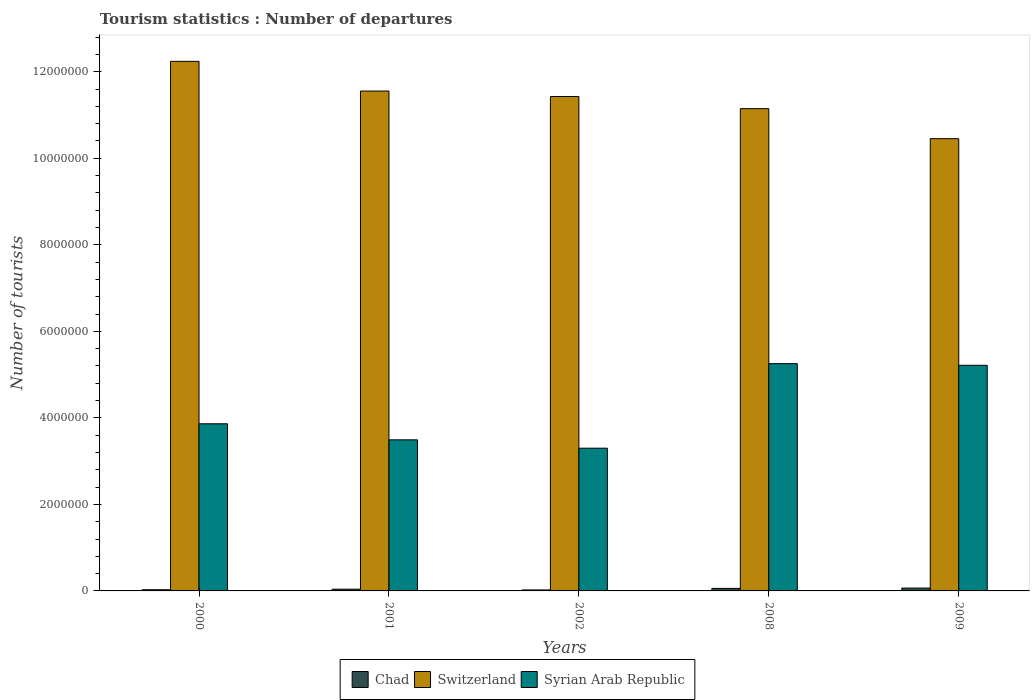How many different coloured bars are there?
Offer a very short reply. 3. What is the label of the 4th group of bars from the left?
Give a very brief answer. 2008. What is the number of tourist departures in Syrian Arab Republic in 2008?
Provide a succinct answer. 5.25e+06. Across all years, what is the maximum number of tourist departures in Chad?
Keep it short and to the point. 6.60e+04. Across all years, what is the minimum number of tourist departures in Syrian Arab Republic?
Your answer should be compact. 3.30e+06. In which year was the number of tourist departures in Syrian Arab Republic minimum?
Ensure brevity in your answer.  2002. What is the total number of tourist departures in Chad in the graph?
Offer a very short reply. 2.14e+05. What is the difference between the number of tourist departures in Switzerland in 2000 and that in 2001?
Give a very brief answer. 6.86e+05. What is the difference between the number of tourist departures in Chad in 2009 and the number of tourist departures in Syrian Arab Republic in 2001?
Your answer should be very brief. -3.43e+06. What is the average number of tourist departures in Switzerland per year?
Provide a short and direct response. 1.14e+07. In the year 2002, what is the difference between the number of tourist departures in Syrian Arab Republic and number of tourist departures in Chad?
Keep it short and to the point. 3.28e+06. In how many years, is the number of tourist departures in Switzerland greater than 8800000?
Provide a short and direct response. 5. What is the ratio of the number of tourist departures in Switzerland in 2001 to that in 2008?
Provide a succinct answer. 1.04. What is the difference between the highest and the second highest number of tourist departures in Chad?
Your answer should be very brief. 8000. What is the difference between the highest and the lowest number of tourist departures in Switzerland?
Your answer should be very brief. 1.79e+06. Is the sum of the number of tourist departures in Switzerland in 2000 and 2001 greater than the maximum number of tourist departures in Chad across all years?
Ensure brevity in your answer.  Yes. What does the 1st bar from the left in 2009 represents?
Provide a short and direct response. Chad. What does the 3rd bar from the right in 2002 represents?
Give a very brief answer. Chad. Is it the case that in every year, the sum of the number of tourist departures in Switzerland and number of tourist departures in Syrian Arab Republic is greater than the number of tourist departures in Chad?
Your response must be concise. Yes. How many bars are there?
Offer a terse response. 15. Are all the bars in the graph horizontal?
Make the answer very short. No. How many years are there in the graph?
Offer a very short reply. 5. What is the difference between two consecutive major ticks on the Y-axis?
Provide a succinct answer. 2.00e+06. Are the values on the major ticks of Y-axis written in scientific E-notation?
Offer a very short reply. No. Does the graph contain any zero values?
Provide a succinct answer. No. Does the graph contain grids?
Your answer should be compact. No. Where does the legend appear in the graph?
Make the answer very short. Bottom center. How are the legend labels stacked?
Keep it short and to the point. Horizontal. What is the title of the graph?
Offer a very short reply. Tourism statistics : Number of departures. What is the label or title of the X-axis?
Make the answer very short. Years. What is the label or title of the Y-axis?
Provide a short and direct response. Number of tourists. What is the Number of tourists in Chad in 2000?
Ensure brevity in your answer.  2.70e+04. What is the Number of tourists in Switzerland in 2000?
Offer a terse response. 1.22e+07. What is the Number of tourists of Syrian Arab Republic in 2000?
Ensure brevity in your answer.  3.86e+06. What is the Number of tourists in Chad in 2001?
Offer a terse response. 4.00e+04. What is the Number of tourists in Switzerland in 2001?
Make the answer very short. 1.16e+07. What is the Number of tourists in Syrian Arab Republic in 2001?
Your answer should be compact. 3.49e+06. What is the Number of tourists in Chad in 2002?
Provide a short and direct response. 2.30e+04. What is the Number of tourists in Switzerland in 2002?
Offer a very short reply. 1.14e+07. What is the Number of tourists in Syrian Arab Republic in 2002?
Provide a succinct answer. 3.30e+06. What is the Number of tourists of Chad in 2008?
Keep it short and to the point. 5.80e+04. What is the Number of tourists in Switzerland in 2008?
Give a very brief answer. 1.11e+07. What is the Number of tourists of Syrian Arab Republic in 2008?
Your answer should be very brief. 5.25e+06. What is the Number of tourists in Chad in 2009?
Your answer should be very brief. 6.60e+04. What is the Number of tourists of Switzerland in 2009?
Keep it short and to the point. 1.05e+07. What is the Number of tourists in Syrian Arab Republic in 2009?
Offer a very short reply. 5.22e+06. Across all years, what is the maximum Number of tourists in Chad?
Your answer should be very brief. 6.60e+04. Across all years, what is the maximum Number of tourists in Switzerland?
Offer a very short reply. 1.22e+07. Across all years, what is the maximum Number of tourists of Syrian Arab Republic?
Provide a short and direct response. 5.25e+06. Across all years, what is the minimum Number of tourists of Chad?
Keep it short and to the point. 2.30e+04. Across all years, what is the minimum Number of tourists of Switzerland?
Ensure brevity in your answer.  1.05e+07. Across all years, what is the minimum Number of tourists in Syrian Arab Republic?
Make the answer very short. 3.30e+06. What is the total Number of tourists in Chad in the graph?
Provide a succinct answer. 2.14e+05. What is the total Number of tourists of Switzerland in the graph?
Keep it short and to the point. 5.68e+07. What is the total Number of tourists of Syrian Arab Republic in the graph?
Give a very brief answer. 2.11e+07. What is the difference between the Number of tourists in Chad in 2000 and that in 2001?
Keep it short and to the point. -1.30e+04. What is the difference between the Number of tourists in Switzerland in 2000 and that in 2001?
Provide a succinct answer. 6.86e+05. What is the difference between the Number of tourists in Syrian Arab Republic in 2000 and that in 2001?
Keep it short and to the point. 3.71e+05. What is the difference between the Number of tourists of Chad in 2000 and that in 2002?
Your answer should be compact. 4000. What is the difference between the Number of tourists of Switzerland in 2000 and that in 2002?
Give a very brief answer. 8.13e+05. What is the difference between the Number of tourists of Syrian Arab Republic in 2000 and that in 2002?
Ensure brevity in your answer.  5.64e+05. What is the difference between the Number of tourists in Chad in 2000 and that in 2008?
Keep it short and to the point. -3.10e+04. What is the difference between the Number of tourists of Switzerland in 2000 and that in 2008?
Your response must be concise. 1.09e+06. What is the difference between the Number of tourists in Syrian Arab Republic in 2000 and that in 2008?
Offer a terse response. -1.39e+06. What is the difference between the Number of tourists in Chad in 2000 and that in 2009?
Provide a succinct answer. -3.90e+04. What is the difference between the Number of tourists in Switzerland in 2000 and that in 2009?
Offer a terse response. 1.79e+06. What is the difference between the Number of tourists in Syrian Arab Republic in 2000 and that in 2009?
Your response must be concise. -1.35e+06. What is the difference between the Number of tourists in Chad in 2001 and that in 2002?
Your answer should be very brief. 1.70e+04. What is the difference between the Number of tourists in Switzerland in 2001 and that in 2002?
Your response must be concise. 1.27e+05. What is the difference between the Number of tourists of Syrian Arab Republic in 2001 and that in 2002?
Your answer should be very brief. 1.93e+05. What is the difference between the Number of tourists of Chad in 2001 and that in 2008?
Offer a terse response. -1.80e+04. What is the difference between the Number of tourists in Switzerland in 2001 and that in 2008?
Ensure brevity in your answer.  4.07e+05. What is the difference between the Number of tourists in Syrian Arab Republic in 2001 and that in 2008?
Provide a short and direct response. -1.76e+06. What is the difference between the Number of tourists in Chad in 2001 and that in 2009?
Offer a very short reply. -2.60e+04. What is the difference between the Number of tourists in Switzerland in 2001 and that in 2009?
Your answer should be very brief. 1.10e+06. What is the difference between the Number of tourists in Syrian Arab Republic in 2001 and that in 2009?
Your response must be concise. -1.72e+06. What is the difference between the Number of tourists of Chad in 2002 and that in 2008?
Offer a terse response. -3.50e+04. What is the difference between the Number of tourists in Switzerland in 2002 and that in 2008?
Keep it short and to the point. 2.80e+05. What is the difference between the Number of tourists in Syrian Arab Republic in 2002 and that in 2008?
Provide a short and direct response. -1.95e+06. What is the difference between the Number of tourists in Chad in 2002 and that in 2009?
Your answer should be compact. -4.30e+04. What is the difference between the Number of tourists of Switzerland in 2002 and that in 2009?
Your answer should be very brief. 9.74e+05. What is the difference between the Number of tourists in Syrian Arab Republic in 2002 and that in 2009?
Keep it short and to the point. -1.92e+06. What is the difference between the Number of tourists of Chad in 2008 and that in 2009?
Your answer should be compact. -8000. What is the difference between the Number of tourists in Switzerland in 2008 and that in 2009?
Keep it short and to the point. 6.94e+05. What is the difference between the Number of tourists of Syrian Arab Republic in 2008 and that in 2009?
Your response must be concise. 3.80e+04. What is the difference between the Number of tourists of Chad in 2000 and the Number of tourists of Switzerland in 2001?
Keep it short and to the point. -1.15e+07. What is the difference between the Number of tourists in Chad in 2000 and the Number of tourists in Syrian Arab Republic in 2001?
Your response must be concise. -3.46e+06. What is the difference between the Number of tourists in Switzerland in 2000 and the Number of tourists in Syrian Arab Republic in 2001?
Offer a very short reply. 8.75e+06. What is the difference between the Number of tourists of Chad in 2000 and the Number of tourists of Switzerland in 2002?
Your answer should be very brief. -1.14e+07. What is the difference between the Number of tourists in Chad in 2000 and the Number of tourists in Syrian Arab Republic in 2002?
Your response must be concise. -3.27e+06. What is the difference between the Number of tourists in Switzerland in 2000 and the Number of tourists in Syrian Arab Republic in 2002?
Offer a very short reply. 8.94e+06. What is the difference between the Number of tourists of Chad in 2000 and the Number of tourists of Switzerland in 2008?
Provide a succinct answer. -1.11e+07. What is the difference between the Number of tourists in Chad in 2000 and the Number of tourists in Syrian Arab Republic in 2008?
Your response must be concise. -5.23e+06. What is the difference between the Number of tourists in Switzerland in 2000 and the Number of tourists in Syrian Arab Republic in 2008?
Provide a short and direct response. 6.99e+06. What is the difference between the Number of tourists of Chad in 2000 and the Number of tourists of Switzerland in 2009?
Ensure brevity in your answer.  -1.04e+07. What is the difference between the Number of tourists in Chad in 2000 and the Number of tourists in Syrian Arab Republic in 2009?
Offer a very short reply. -5.19e+06. What is the difference between the Number of tourists of Switzerland in 2000 and the Number of tourists of Syrian Arab Republic in 2009?
Offer a very short reply. 7.02e+06. What is the difference between the Number of tourists in Chad in 2001 and the Number of tourists in Switzerland in 2002?
Keep it short and to the point. -1.14e+07. What is the difference between the Number of tourists in Chad in 2001 and the Number of tourists in Syrian Arab Republic in 2002?
Your answer should be compact. -3.26e+06. What is the difference between the Number of tourists in Switzerland in 2001 and the Number of tourists in Syrian Arab Republic in 2002?
Your response must be concise. 8.26e+06. What is the difference between the Number of tourists in Chad in 2001 and the Number of tourists in Switzerland in 2008?
Make the answer very short. -1.11e+07. What is the difference between the Number of tourists in Chad in 2001 and the Number of tourists in Syrian Arab Republic in 2008?
Provide a succinct answer. -5.21e+06. What is the difference between the Number of tourists in Switzerland in 2001 and the Number of tourists in Syrian Arab Republic in 2008?
Provide a succinct answer. 6.30e+06. What is the difference between the Number of tourists of Chad in 2001 and the Number of tourists of Switzerland in 2009?
Your response must be concise. -1.04e+07. What is the difference between the Number of tourists of Chad in 2001 and the Number of tourists of Syrian Arab Republic in 2009?
Ensure brevity in your answer.  -5.18e+06. What is the difference between the Number of tourists in Switzerland in 2001 and the Number of tourists in Syrian Arab Republic in 2009?
Make the answer very short. 6.34e+06. What is the difference between the Number of tourists of Chad in 2002 and the Number of tourists of Switzerland in 2008?
Your answer should be very brief. -1.11e+07. What is the difference between the Number of tourists of Chad in 2002 and the Number of tourists of Syrian Arab Republic in 2008?
Give a very brief answer. -5.23e+06. What is the difference between the Number of tourists in Switzerland in 2002 and the Number of tourists in Syrian Arab Republic in 2008?
Your answer should be compact. 6.17e+06. What is the difference between the Number of tourists of Chad in 2002 and the Number of tourists of Switzerland in 2009?
Give a very brief answer. -1.04e+07. What is the difference between the Number of tourists in Chad in 2002 and the Number of tourists in Syrian Arab Republic in 2009?
Offer a terse response. -5.19e+06. What is the difference between the Number of tourists of Switzerland in 2002 and the Number of tourists of Syrian Arab Republic in 2009?
Offer a very short reply. 6.21e+06. What is the difference between the Number of tourists of Chad in 2008 and the Number of tourists of Switzerland in 2009?
Your response must be concise. -1.04e+07. What is the difference between the Number of tourists of Chad in 2008 and the Number of tourists of Syrian Arab Republic in 2009?
Give a very brief answer. -5.16e+06. What is the difference between the Number of tourists in Switzerland in 2008 and the Number of tourists in Syrian Arab Republic in 2009?
Offer a very short reply. 5.93e+06. What is the average Number of tourists of Chad per year?
Your answer should be very brief. 4.28e+04. What is the average Number of tourists in Switzerland per year?
Your response must be concise. 1.14e+07. What is the average Number of tourists of Syrian Arab Republic per year?
Your answer should be very brief. 4.22e+06. In the year 2000, what is the difference between the Number of tourists of Chad and Number of tourists of Switzerland?
Keep it short and to the point. -1.22e+07. In the year 2000, what is the difference between the Number of tourists in Chad and Number of tourists in Syrian Arab Republic?
Your answer should be very brief. -3.84e+06. In the year 2000, what is the difference between the Number of tourists in Switzerland and Number of tourists in Syrian Arab Republic?
Offer a very short reply. 8.38e+06. In the year 2001, what is the difference between the Number of tourists of Chad and Number of tourists of Switzerland?
Provide a short and direct response. -1.15e+07. In the year 2001, what is the difference between the Number of tourists in Chad and Number of tourists in Syrian Arab Republic?
Make the answer very short. -3.45e+06. In the year 2001, what is the difference between the Number of tourists in Switzerland and Number of tourists in Syrian Arab Republic?
Keep it short and to the point. 8.06e+06. In the year 2002, what is the difference between the Number of tourists in Chad and Number of tourists in Switzerland?
Offer a terse response. -1.14e+07. In the year 2002, what is the difference between the Number of tourists of Chad and Number of tourists of Syrian Arab Republic?
Give a very brief answer. -3.28e+06. In the year 2002, what is the difference between the Number of tourists in Switzerland and Number of tourists in Syrian Arab Republic?
Offer a very short reply. 8.13e+06. In the year 2008, what is the difference between the Number of tourists of Chad and Number of tourists of Switzerland?
Give a very brief answer. -1.11e+07. In the year 2008, what is the difference between the Number of tourists in Chad and Number of tourists in Syrian Arab Republic?
Make the answer very short. -5.20e+06. In the year 2008, what is the difference between the Number of tourists in Switzerland and Number of tourists in Syrian Arab Republic?
Make the answer very short. 5.89e+06. In the year 2009, what is the difference between the Number of tourists of Chad and Number of tourists of Switzerland?
Make the answer very short. -1.04e+07. In the year 2009, what is the difference between the Number of tourists in Chad and Number of tourists in Syrian Arab Republic?
Your answer should be very brief. -5.15e+06. In the year 2009, what is the difference between the Number of tourists of Switzerland and Number of tourists of Syrian Arab Republic?
Your answer should be compact. 5.24e+06. What is the ratio of the Number of tourists in Chad in 2000 to that in 2001?
Your answer should be very brief. 0.68. What is the ratio of the Number of tourists in Switzerland in 2000 to that in 2001?
Keep it short and to the point. 1.06. What is the ratio of the Number of tourists in Syrian Arab Republic in 2000 to that in 2001?
Provide a succinct answer. 1.11. What is the ratio of the Number of tourists in Chad in 2000 to that in 2002?
Your response must be concise. 1.17. What is the ratio of the Number of tourists of Switzerland in 2000 to that in 2002?
Your response must be concise. 1.07. What is the ratio of the Number of tourists in Syrian Arab Republic in 2000 to that in 2002?
Provide a short and direct response. 1.17. What is the ratio of the Number of tourists in Chad in 2000 to that in 2008?
Keep it short and to the point. 0.47. What is the ratio of the Number of tourists of Switzerland in 2000 to that in 2008?
Offer a terse response. 1.1. What is the ratio of the Number of tourists in Syrian Arab Republic in 2000 to that in 2008?
Give a very brief answer. 0.74. What is the ratio of the Number of tourists of Chad in 2000 to that in 2009?
Offer a very short reply. 0.41. What is the ratio of the Number of tourists in Switzerland in 2000 to that in 2009?
Offer a very short reply. 1.17. What is the ratio of the Number of tourists in Syrian Arab Republic in 2000 to that in 2009?
Your answer should be compact. 0.74. What is the ratio of the Number of tourists in Chad in 2001 to that in 2002?
Your answer should be compact. 1.74. What is the ratio of the Number of tourists of Switzerland in 2001 to that in 2002?
Your response must be concise. 1.01. What is the ratio of the Number of tourists in Syrian Arab Republic in 2001 to that in 2002?
Offer a very short reply. 1.06. What is the ratio of the Number of tourists of Chad in 2001 to that in 2008?
Your answer should be very brief. 0.69. What is the ratio of the Number of tourists of Switzerland in 2001 to that in 2008?
Provide a short and direct response. 1.04. What is the ratio of the Number of tourists of Syrian Arab Republic in 2001 to that in 2008?
Keep it short and to the point. 0.66. What is the ratio of the Number of tourists of Chad in 2001 to that in 2009?
Give a very brief answer. 0.61. What is the ratio of the Number of tourists in Switzerland in 2001 to that in 2009?
Make the answer very short. 1.11. What is the ratio of the Number of tourists in Syrian Arab Republic in 2001 to that in 2009?
Offer a very short reply. 0.67. What is the ratio of the Number of tourists of Chad in 2002 to that in 2008?
Your answer should be compact. 0.4. What is the ratio of the Number of tourists of Switzerland in 2002 to that in 2008?
Offer a very short reply. 1.03. What is the ratio of the Number of tourists of Syrian Arab Republic in 2002 to that in 2008?
Offer a terse response. 0.63. What is the ratio of the Number of tourists of Chad in 2002 to that in 2009?
Ensure brevity in your answer.  0.35. What is the ratio of the Number of tourists in Switzerland in 2002 to that in 2009?
Offer a terse response. 1.09. What is the ratio of the Number of tourists in Syrian Arab Republic in 2002 to that in 2009?
Keep it short and to the point. 0.63. What is the ratio of the Number of tourists in Chad in 2008 to that in 2009?
Offer a very short reply. 0.88. What is the ratio of the Number of tourists of Switzerland in 2008 to that in 2009?
Offer a terse response. 1.07. What is the ratio of the Number of tourists in Syrian Arab Republic in 2008 to that in 2009?
Offer a very short reply. 1.01. What is the difference between the highest and the second highest Number of tourists in Chad?
Give a very brief answer. 8000. What is the difference between the highest and the second highest Number of tourists in Switzerland?
Your answer should be compact. 6.86e+05. What is the difference between the highest and the second highest Number of tourists of Syrian Arab Republic?
Offer a terse response. 3.80e+04. What is the difference between the highest and the lowest Number of tourists of Chad?
Give a very brief answer. 4.30e+04. What is the difference between the highest and the lowest Number of tourists in Switzerland?
Your response must be concise. 1.79e+06. What is the difference between the highest and the lowest Number of tourists in Syrian Arab Republic?
Your response must be concise. 1.95e+06. 